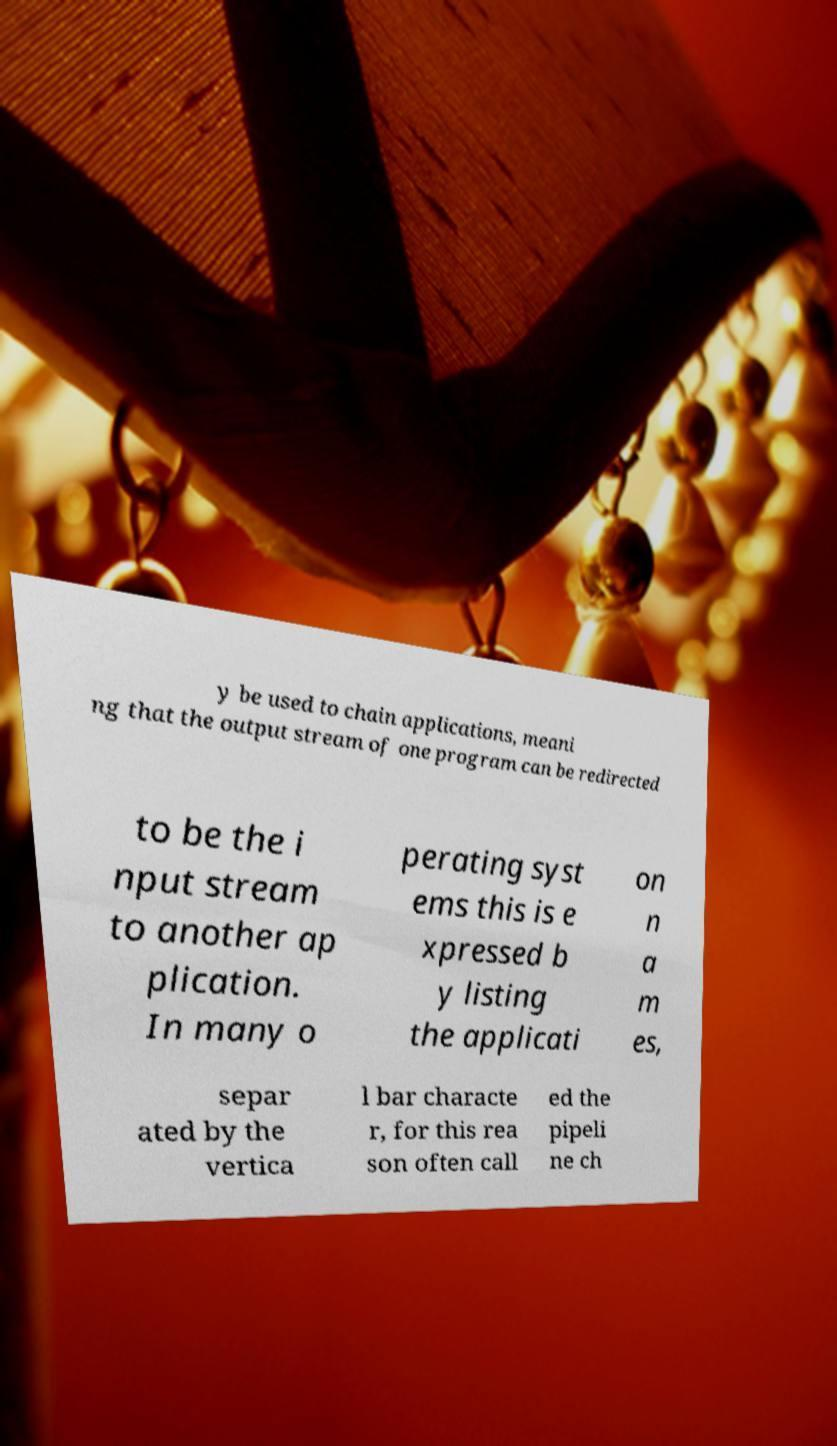Please read and relay the text visible in this image. What does it say? y be used to chain applications, meani ng that the output stream of one program can be redirected to be the i nput stream to another ap plication. In many o perating syst ems this is e xpressed b y listing the applicati on n a m es, separ ated by the vertica l bar characte r, for this rea son often call ed the pipeli ne ch 